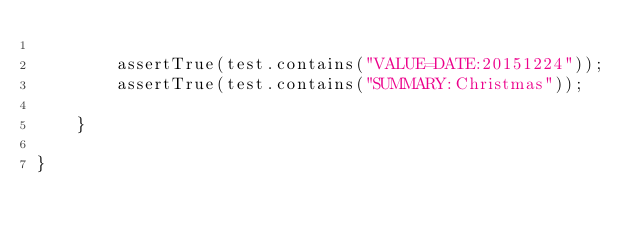Convert code to text. <code><loc_0><loc_0><loc_500><loc_500><_Java_>
        assertTrue(test.contains("VALUE=DATE:20151224"));
        assertTrue(test.contains("SUMMARY:Christmas"));

    }

}
</code> 